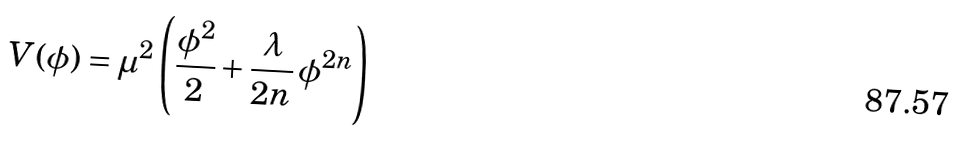Convert formula to latex. <formula><loc_0><loc_0><loc_500><loc_500>V ( \phi ) = \mu ^ { 2 } \left ( \frac { \phi ^ { 2 } } { 2 } + \frac { \lambda } { 2 n } \, \phi ^ { 2 n } \right )</formula> 